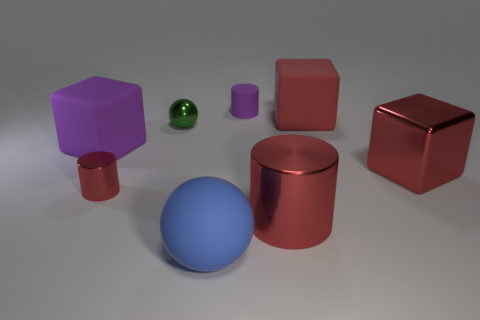What material do the objects appear to be made of? The objects in the image seem to have different materials. The red and blue cylinders, along with the blue sphere and the red cube on the right, appear to have a metallic finish due to their reflective surfaces. The purple cube and the small green sphere look to be made of a matte material, possibly rubber, as they have a less reflective finish. 